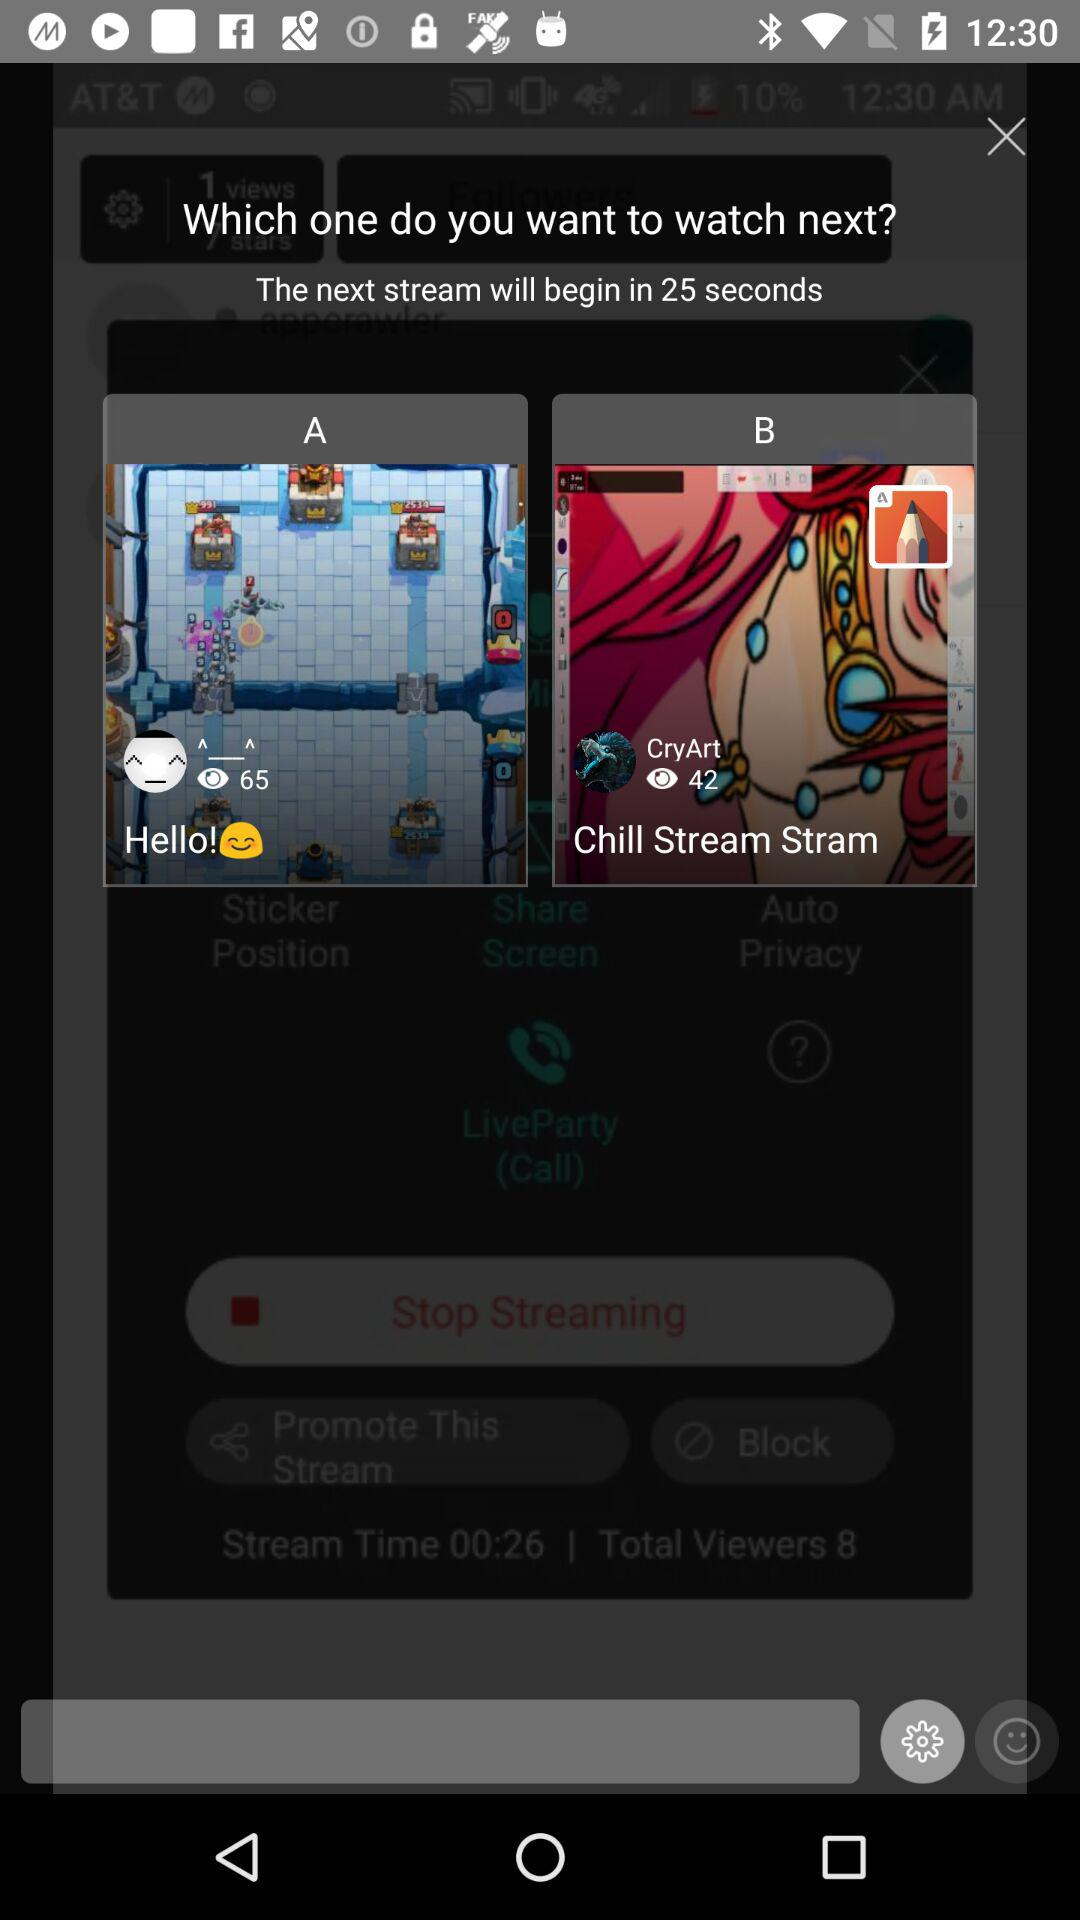How many seconds until the next stream begins?
Answer the question using a single word or phrase. 25 